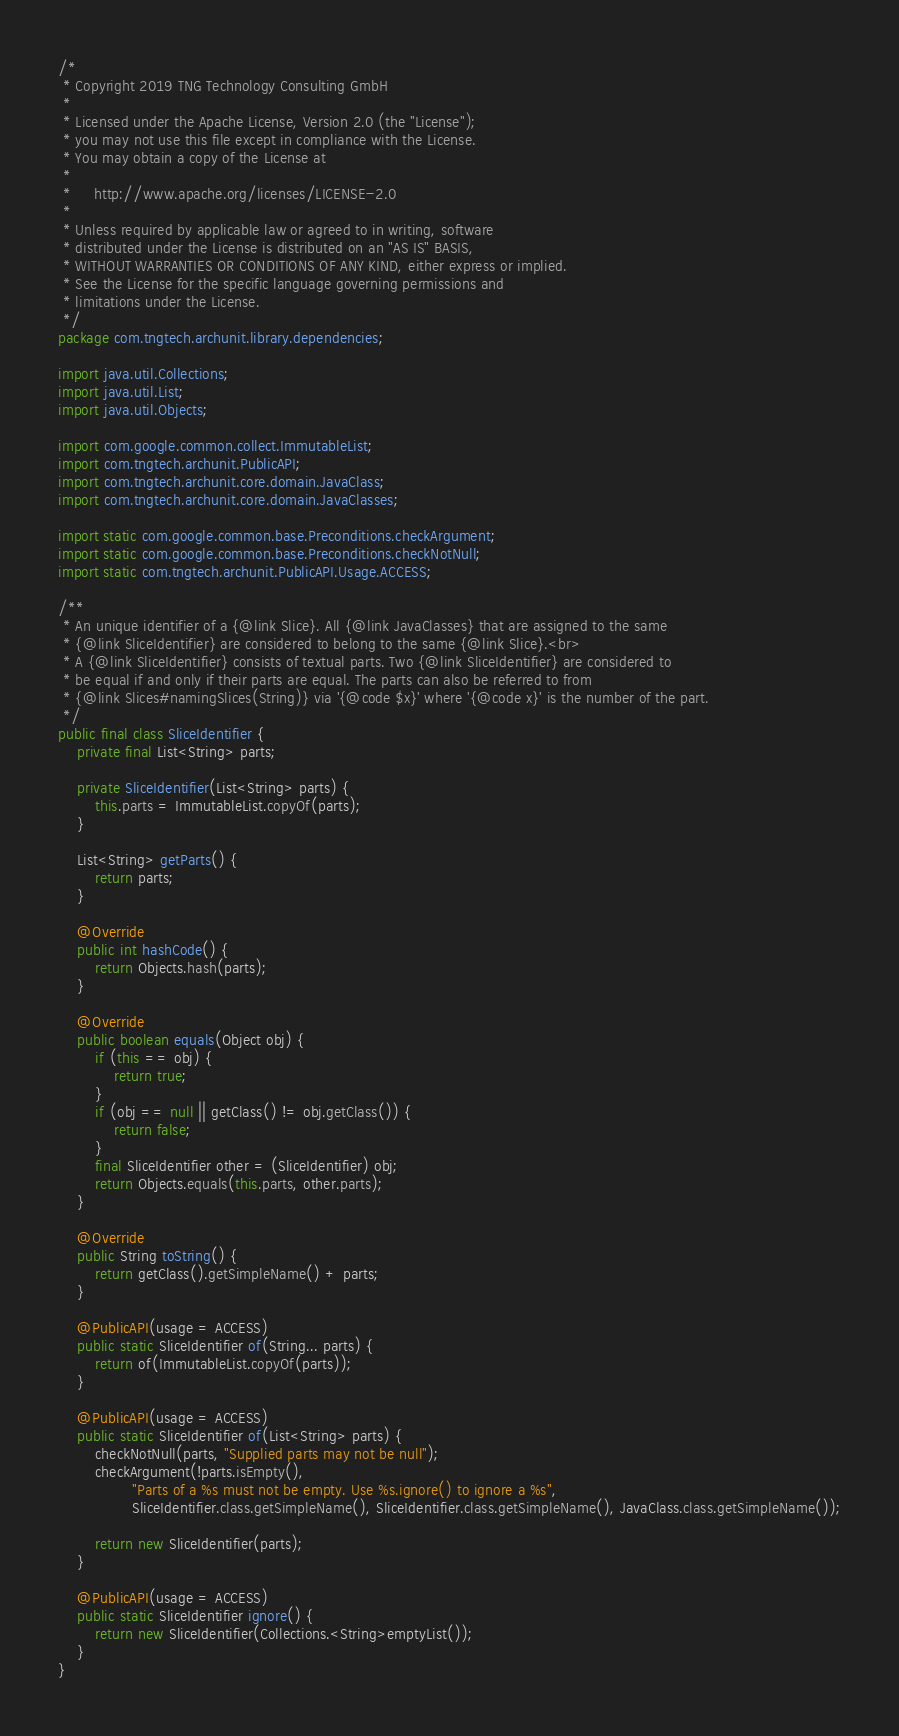Convert code to text. <code><loc_0><loc_0><loc_500><loc_500><_Java_>/*
 * Copyright 2019 TNG Technology Consulting GmbH
 *
 * Licensed under the Apache License, Version 2.0 (the "License");
 * you may not use this file except in compliance with the License.
 * You may obtain a copy of the License at
 *
 *     http://www.apache.org/licenses/LICENSE-2.0
 *
 * Unless required by applicable law or agreed to in writing, software
 * distributed under the License is distributed on an "AS IS" BASIS,
 * WITHOUT WARRANTIES OR CONDITIONS OF ANY KIND, either express or implied.
 * See the License for the specific language governing permissions and
 * limitations under the License.
 */
package com.tngtech.archunit.library.dependencies;

import java.util.Collections;
import java.util.List;
import java.util.Objects;

import com.google.common.collect.ImmutableList;
import com.tngtech.archunit.PublicAPI;
import com.tngtech.archunit.core.domain.JavaClass;
import com.tngtech.archunit.core.domain.JavaClasses;

import static com.google.common.base.Preconditions.checkArgument;
import static com.google.common.base.Preconditions.checkNotNull;
import static com.tngtech.archunit.PublicAPI.Usage.ACCESS;

/**
 * An unique identifier of a {@link Slice}. All {@link JavaClasses} that are assigned to the same
 * {@link SliceIdentifier} are considered to belong to the same {@link Slice}.<br>
 * A {@link SliceIdentifier} consists of textual parts. Two {@link SliceIdentifier} are considered to
 * be equal if and only if their parts are equal. The parts can also be referred to from
 * {@link Slices#namingSlices(String)} via '{@code $x}' where '{@code x}' is the number of the part.
 */
public final class SliceIdentifier {
    private final List<String> parts;

    private SliceIdentifier(List<String> parts) {
        this.parts = ImmutableList.copyOf(parts);
    }

    List<String> getParts() {
        return parts;
    }

    @Override
    public int hashCode() {
        return Objects.hash(parts);
    }

    @Override
    public boolean equals(Object obj) {
        if (this == obj) {
            return true;
        }
        if (obj == null || getClass() != obj.getClass()) {
            return false;
        }
        final SliceIdentifier other = (SliceIdentifier) obj;
        return Objects.equals(this.parts, other.parts);
    }

    @Override
    public String toString() {
        return getClass().getSimpleName() + parts;
    }

    @PublicAPI(usage = ACCESS)
    public static SliceIdentifier of(String... parts) {
        return of(ImmutableList.copyOf(parts));
    }

    @PublicAPI(usage = ACCESS)
    public static SliceIdentifier of(List<String> parts) {
        checkNotNull(parts, "Supplied parts may not be null");
        checkArgument(!parts.isEmpty(),
                "Parts of a %s must not be empty. Use %s.ignore() to ignore a %s",
                SliceIdentifier.class.getSimpleName(), SliceIdentifier.class.getSimpleName(), JavaClass.class.getSimpleName());

        return new SliceIdentifier(parts);
    }

    @PublicAPI(usage = ACCESS)
    public static SliceIdentifier ignore() {
        return new SliceIdentifier(Collections.<String>emptyList());
    }
}
</code> 